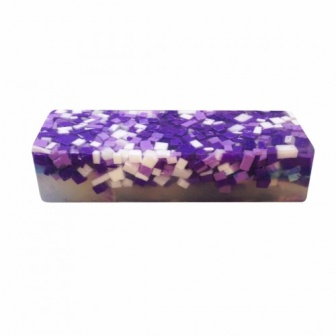If this soap was included in a mystery novel, what role could it play? In a mystery novel, this soap could serve as an important clue or pivotal plot device. Perhaps it belongs to a character who is central to the storyline, and its distinctive mosaic pattern becomes a unique identifier linking the soap to a crucial scene. Alternatively, its colors and design could hide secret messages or codes that the protagonist must decipher to unravel a larger mystery. Its luxurious and uncommon appearance could signify wealth or exclusivity, adding layers of intrigue and complexity to the narrative. 